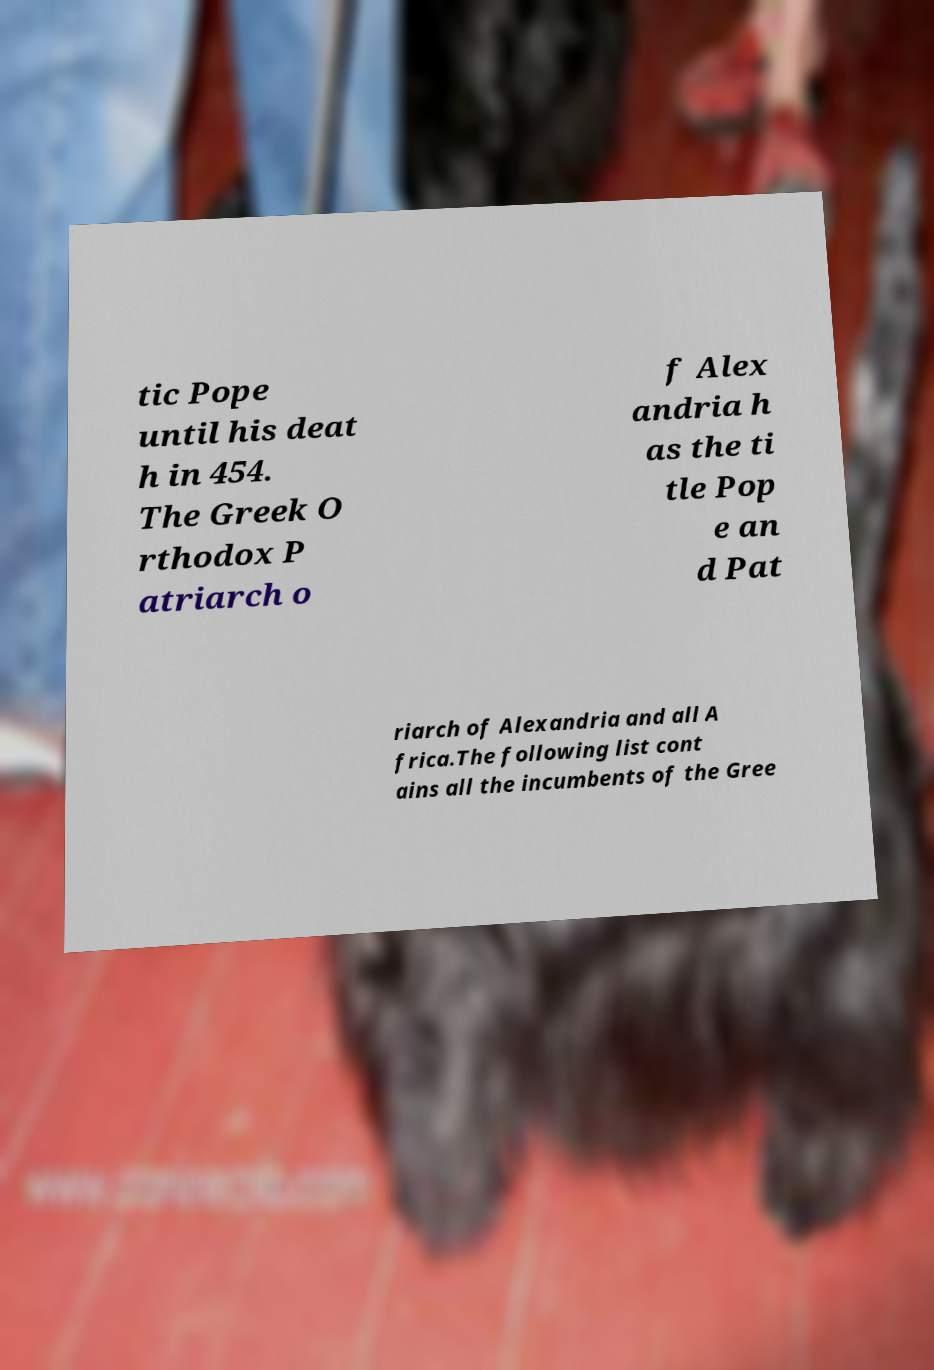What messages or text are displayed in this image? I need them in a readable, typed format. tic Pope until his deat h in 454. The Greek O rthodox P atriarch o f Alex andria h as the ti tle Pop e an d Pat riarch of Alexandria and all A frica.The following list cont ains all the incumbents of the Gree 